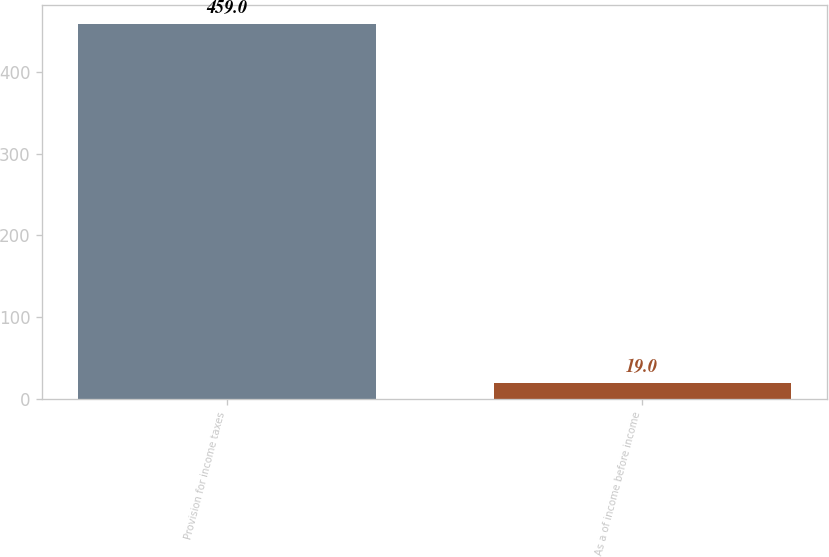Convert chart. <chart><loc_0><loc_0><loc_500><loc_500><bar_chart><fcel>Provision for income taxes<fcel>As a of income before income<nl><fcel>459<fcel>19<nl></chart> 